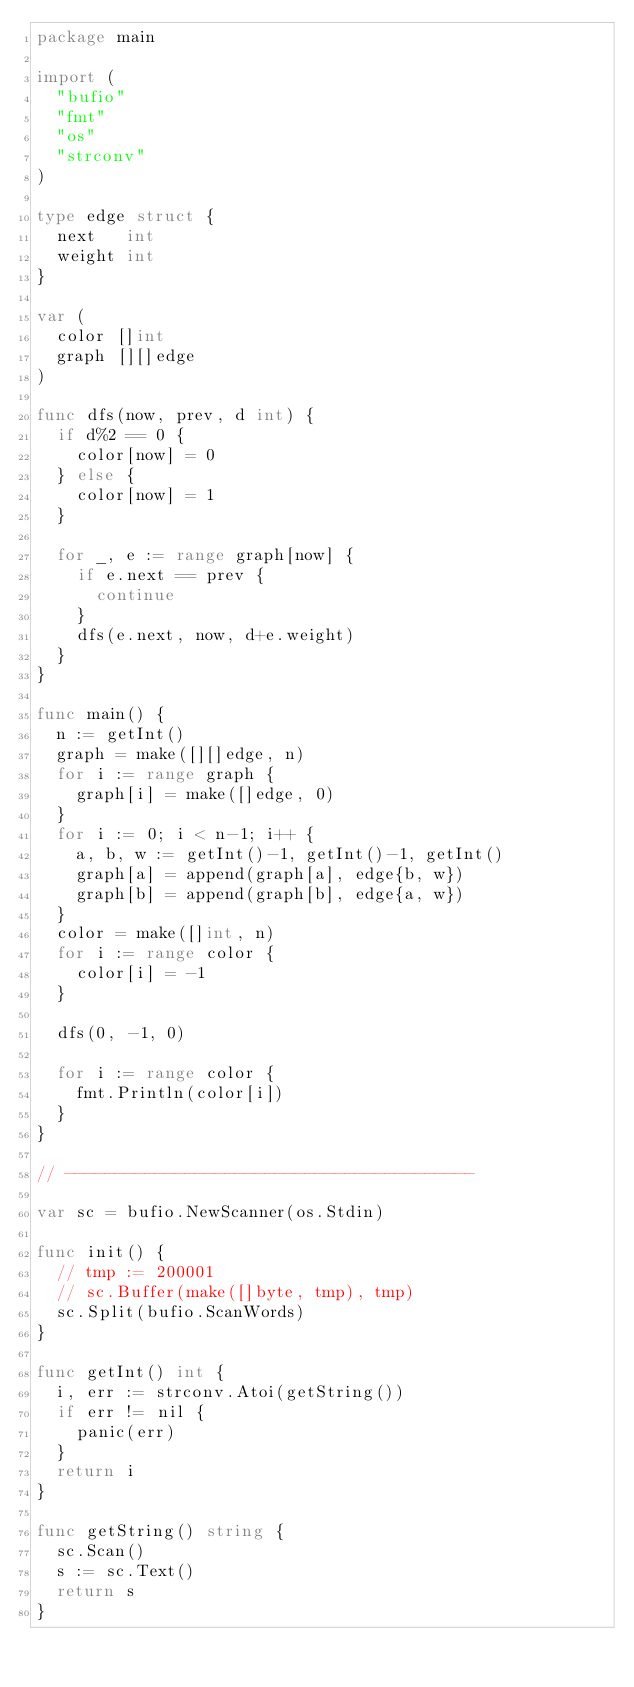<code> <loc_0><loc_0><loc_500><loc_500><_Go_>package main

import (
	"bufio"
	"fmt"
	"os"
	"strconv"
)

type edge struct {
	next   int
	weight int
}

var (
	color []int
	graph [][]edge
)

func dfs(now, prev, d int) {
	if d%2 == 0 {
		color[now] = 0
	} else {
		color[now] = 1
	}

	for _, e := range graph[now] {
		if e.next == prev {
			continue
		}
		dfs(e.next, now, d+e.weight)
	}
}

func main() {
	n := getInt()
	graph = make([][]edge, n)
	for i := range graph {
		graph[i] = make([]edge, 0)
	}
	for i := 0; i < n-1; i++ {
		a, b, w := getInt()-1, getInt()-1, getInt()
		graph[a] = append(graph[a], edge{b, w})
		graph[b] = append(graph[b], edge{a, w})
	}
	color = make([]int, n)
	for i := range color {
		color[i] = -1
	}

	dfs(0, -1, 0)

	for i := range color {
		fmt.Println(color[i])
	}
}

// -----------------------------------------

var sc = bufio.NewScanner(os.Stdin)

func init() {
	// tmp := 200001
	// sc.Buffer(make([]byte, tmp), tmp)
	sc.Split(bufio.ScanWords)
}

func getInt() int {
	i, err := strconv.Atoi(getString())
	if err != nil {
		panic(err)
	}
	return i
}

func getString() string {
	sc.Scan()
	s := sc.Text()
	return s
}
</code> 